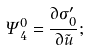<formula> <loc_0><loc_0><loc_500><loc_500>\Psi _ { 4 } ^ { 0 } = \frac { \partial \sigma ^ { \prime } _ { 0 } } { \partial \tilde { u } } ;</formula> 